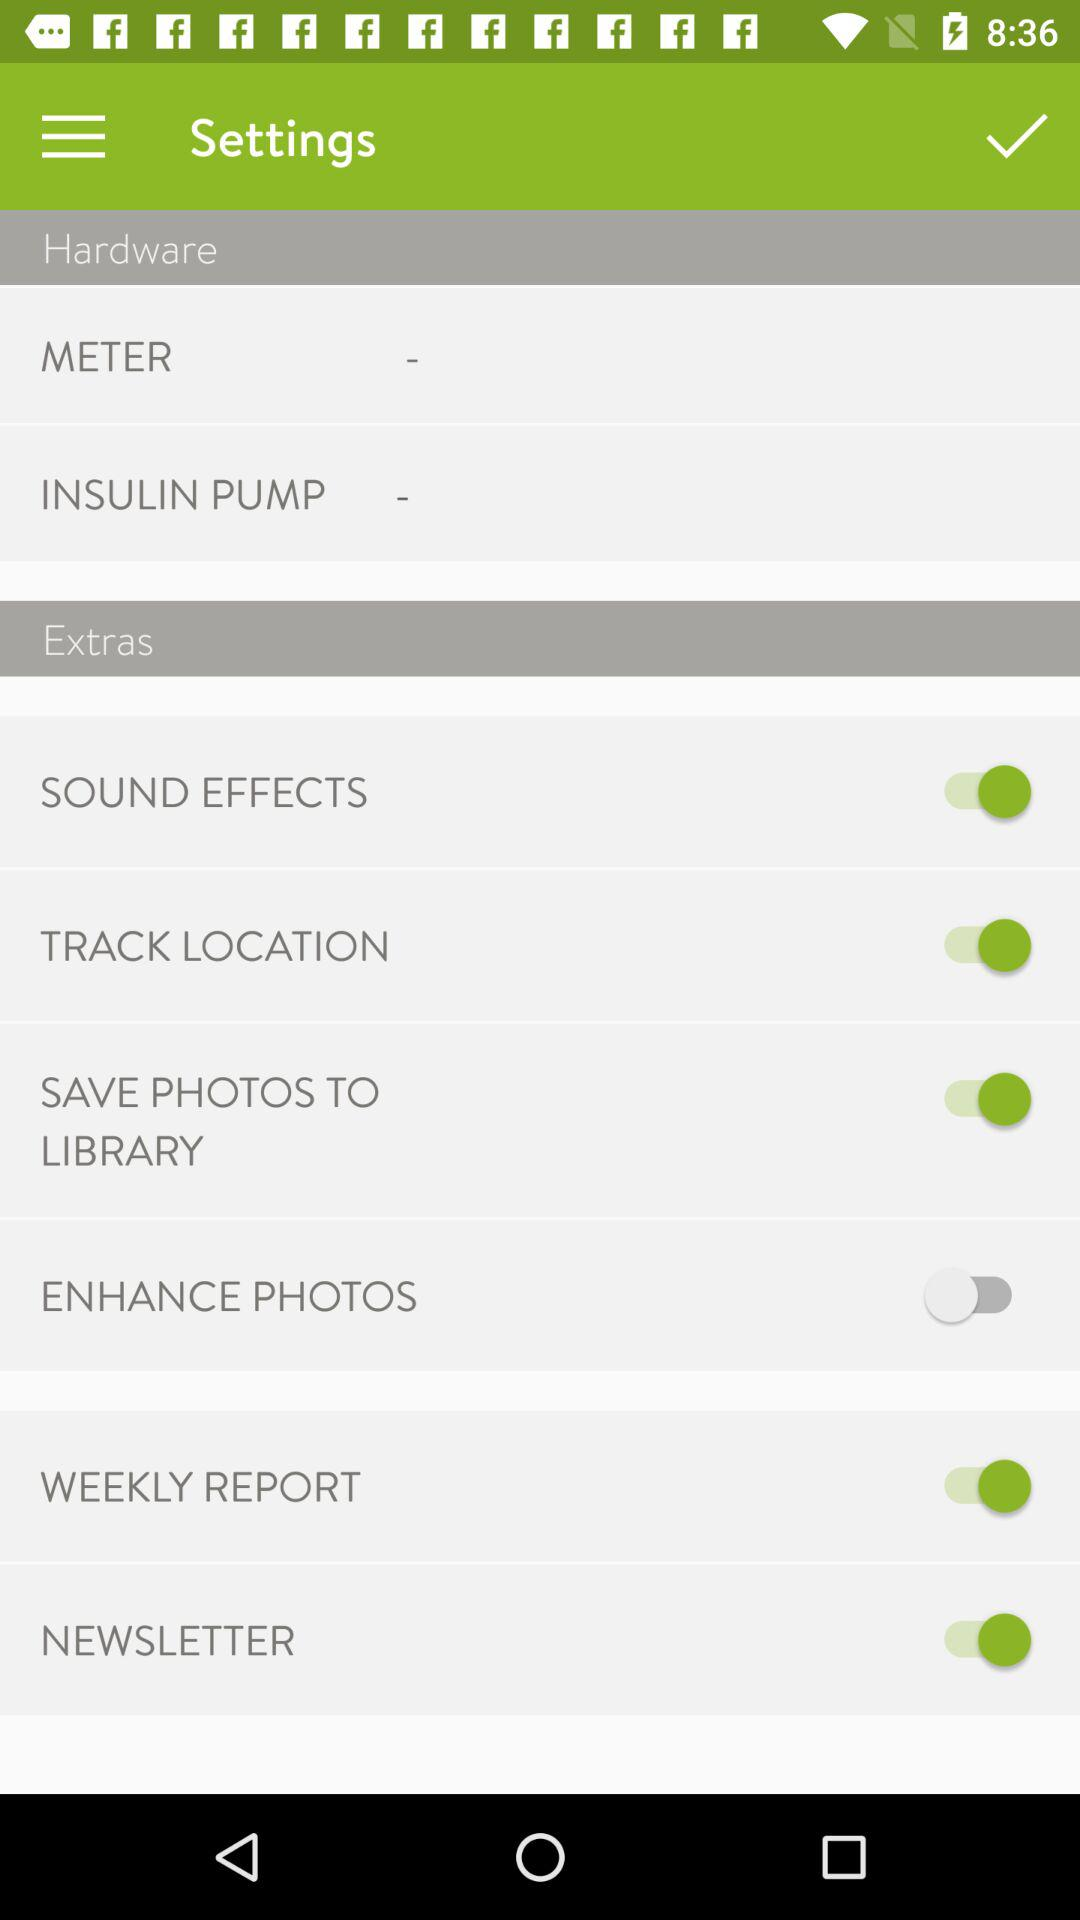What is the status of "SOUND EFFECTS"? The status is "on". 